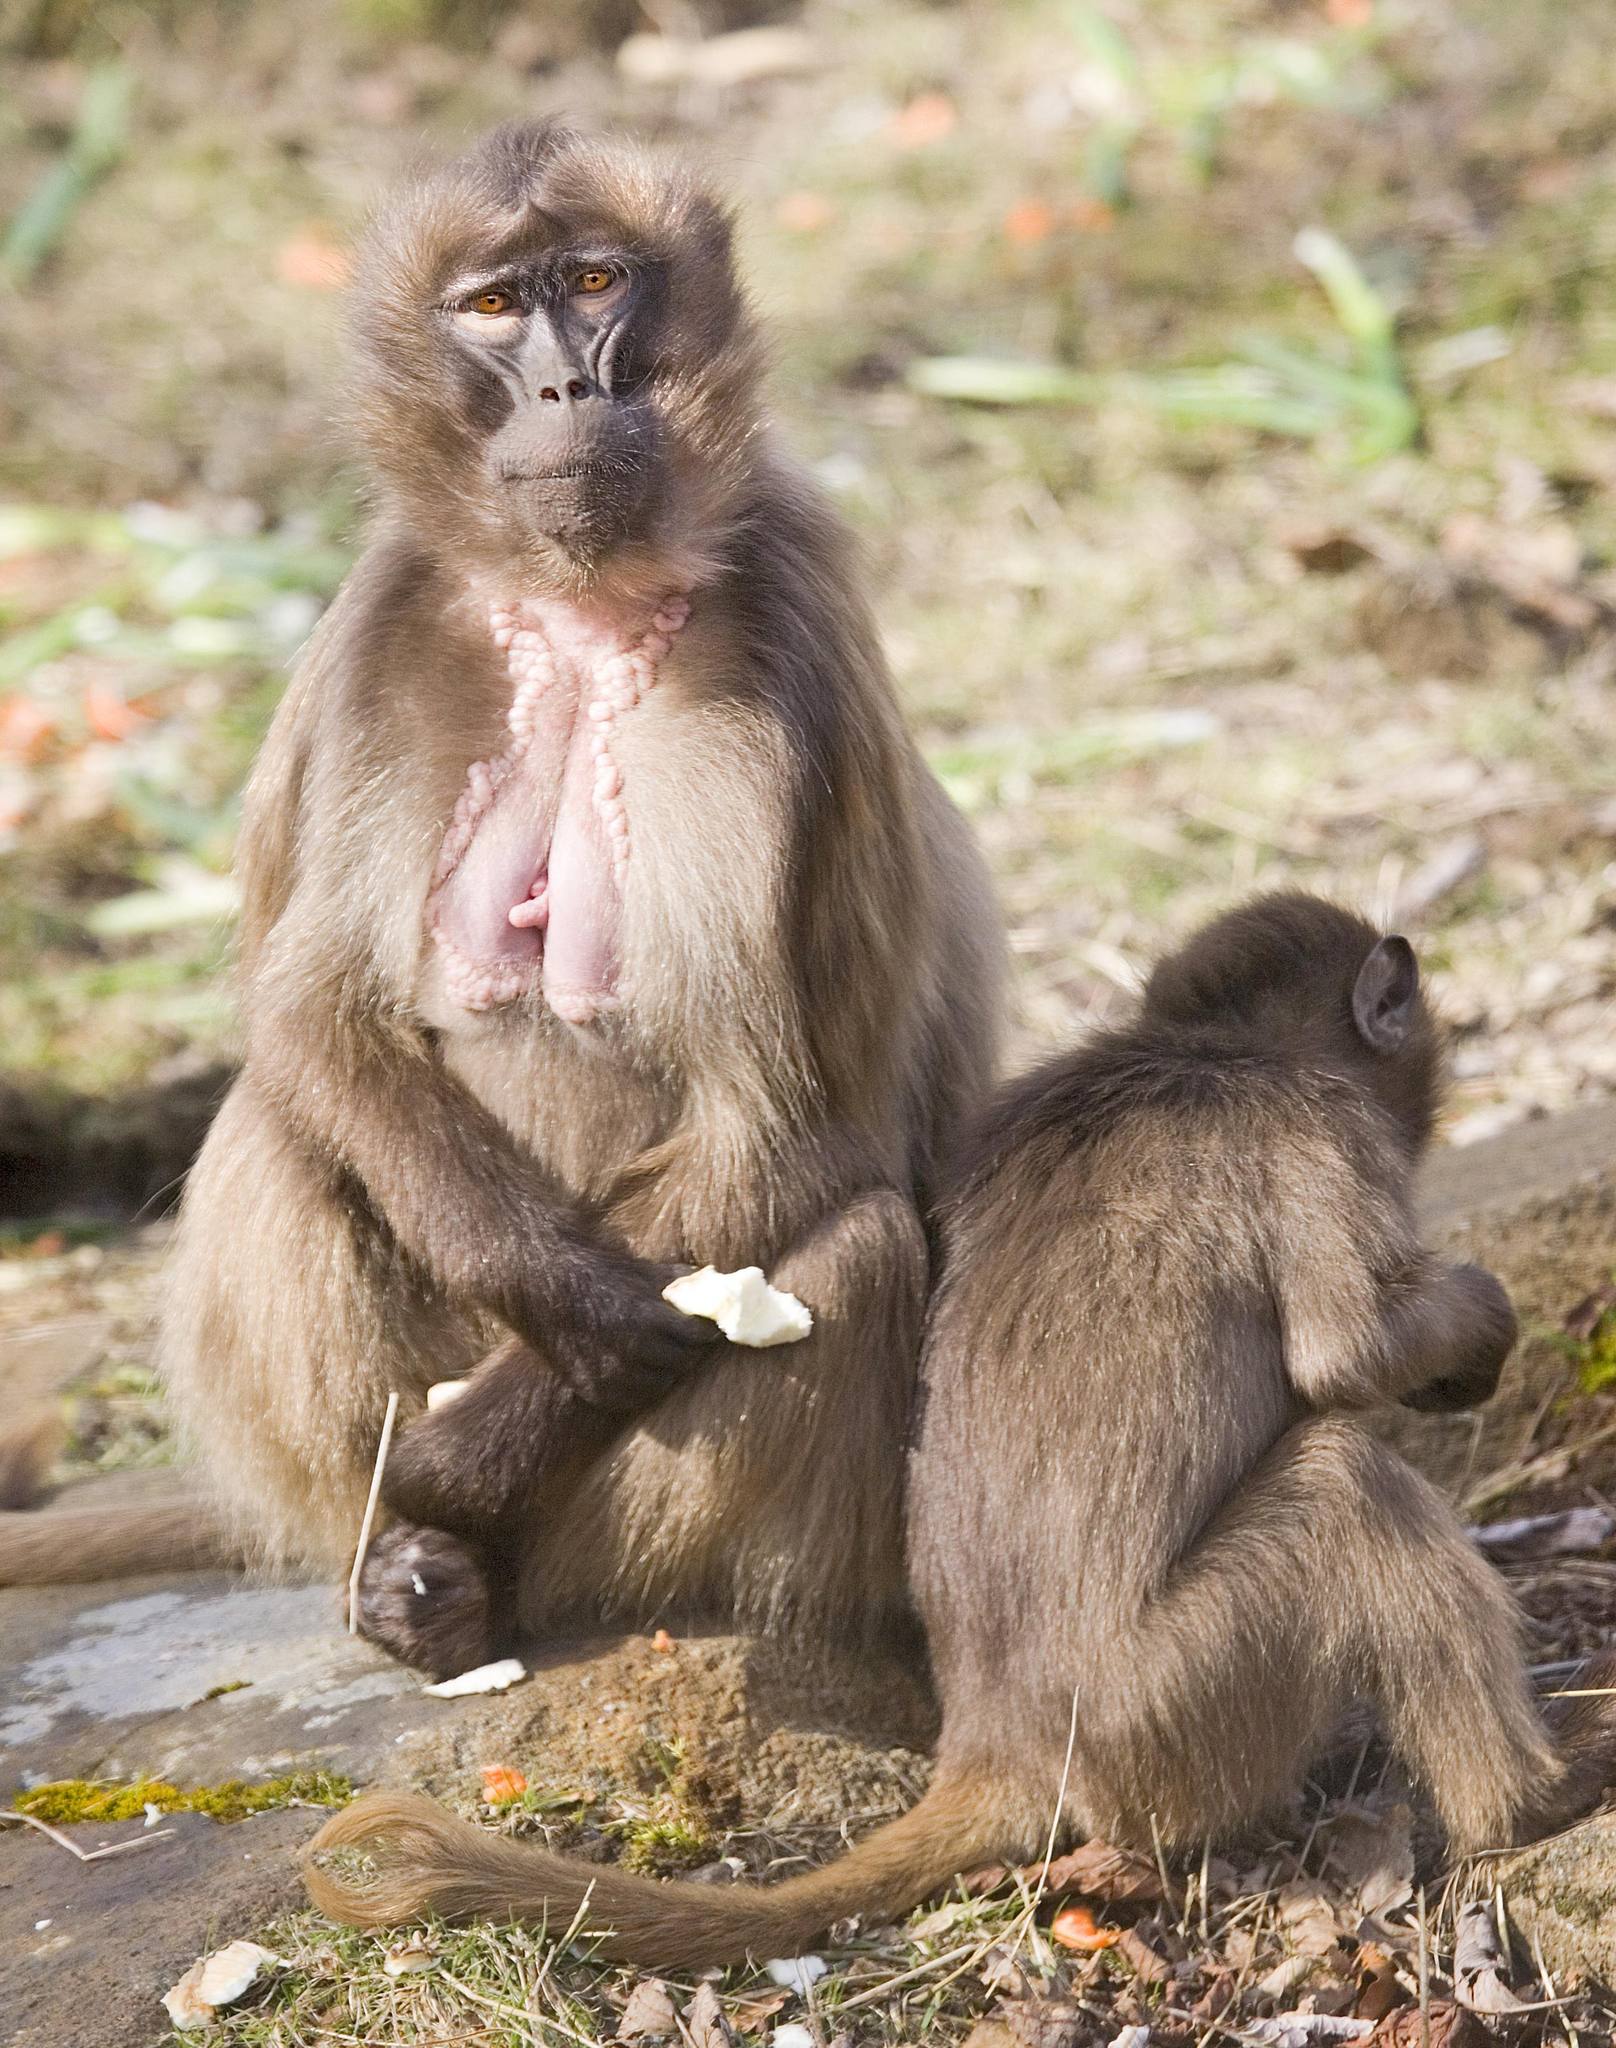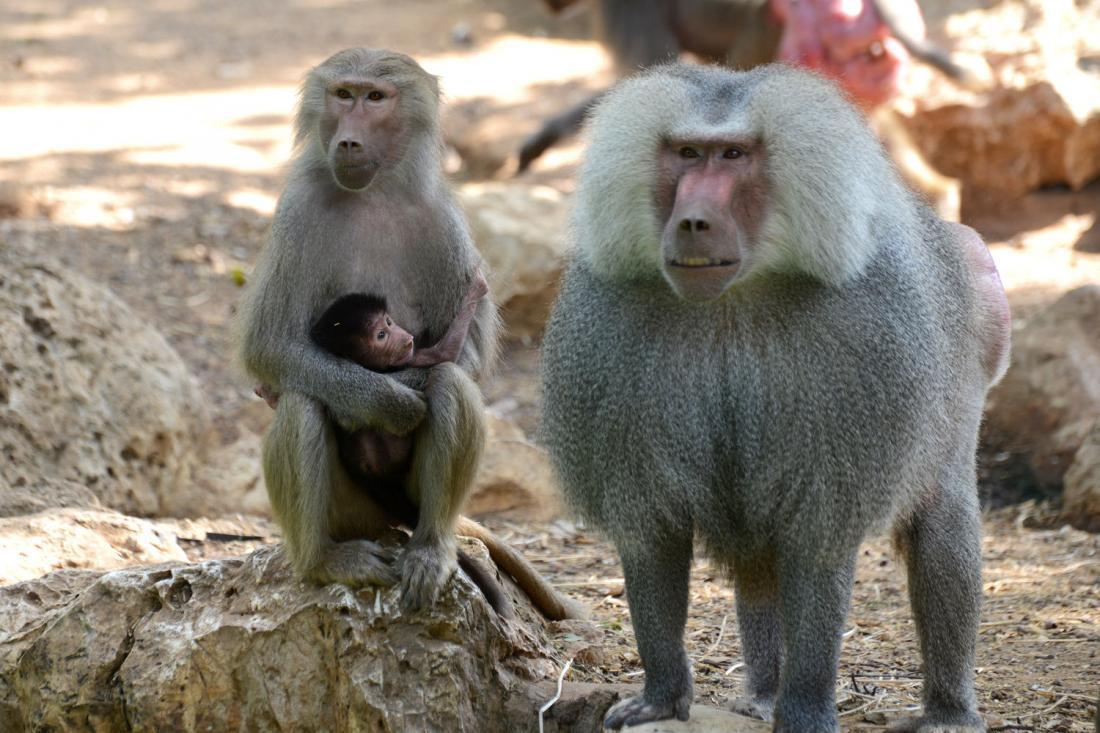The first image is the image on the left, the second image is the image on the right. For the images displayed, is the sentence "A baboon is hugging an animal to its chest in one image." factually correct? Answer yes or no. Yes. The first image is the image on the left, the second image is the image on the right. Assess this claim about the two images: "In one of the images there is a baby monkey cuddled in the arms of an adult monkey.". Correct or not? Answer yes or no. Yes. 